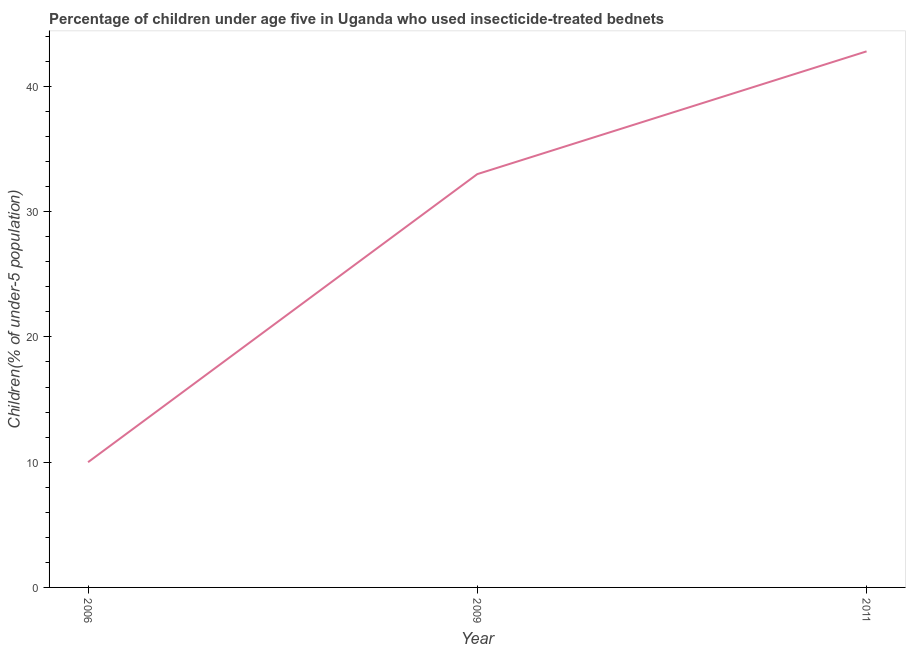What is the percentage of children who use of insecticide-treated bed nets in 2009?
Provide a short and direct response. 33. Across all years, what is the maximum percentage of children who use of insecticide-treated bed nets?
Keep it short and to the point. 42.8. In which year was the percentage of children who use of insecticide-treated bed nets maximum?
Give a very brief answer. 2011. What is the sum of the percentage of children who use of insecticide-treated bed nets?
Provide a succinct answer. 85.8. What is the average percentage of children who use of insecticide-treated bed nets per year?
Provide a short and direct response. 28.6. In how many years, is the percentage of children who use of insecticide-treated bed nets greater than 24 %?
Your response must be concise. 2. What is the ratio of the percentage of children who use of insecticide-treated bed nets in 2006 to that in 2009?
Make the answer very short. 0.3. Is the percentage of children who use of insecticide-treated bed nets in 2006 less than that in 2009?
Provide a succinct answer. Yes. Is the difference between the percentage of children who use of insecticide-treated bed nets in 2006 and 2011 greater than the difference between any two years?
Make the answer very short. Yes. What is the difference between the highest and the second highest percentage of children who use of insecticide-treated bed nets?
Provide a short and direct response. 9.8. What is the difference between the highest and the lowest percentage of children who use of insecticide-treated bed nets?
Ensure brevity in your answer.  32.8. In how many years, is the percentage of children who use of insecticide-treated bed nets greater than the average percentage of children who use of insecticide-treated bed nets taken over all years?
Make the answer very short. 2. Does the percentage of children who use of insecticide-treated bed nets monotonically increase over the years?
Give a very brief answer. Yes. How many years are there in the graph?
Provide a succinct answer. 3. What is the difference between two consecutive major ticks on the Y-axis?
Offer a very short reply. 10. What is the title of the graph?
Make the answer very short. Percentage of children under age five in Uganda who used insecticide-treated bednets. What is the label or title of the X-axis?
Provide a succinct answer. Year. What is the label or title of the Y-axis?
Your response must be concise. Children(% of under-5 population). What is the Children(% of under-5 population) in 2011?
Your answer should be compact. 42.8. What is the difference between the Children(% of under-5 population) in 2006 and 2009?
Keep it short and to the point. -23. What is the difference between the Children(% of under-5 population) in 2006 and 2011?
Ensure brevity in your answer.  -32.8. What is the difference between the Children(% of under-5 population) in 2009 and 2011?
Your answer should be compact. -9.8. What is the ratio of the Children(% of under-5 population) in 2006 to that in 2009?
Your answer should be compact. 0.3. What is the ratio of the Children(% of under-5 population) in 2006 to that in 2011?
Your answer should be compact. 0.23. What is the ratio of the Children(% of under-5 population) in 2009 to that in 2011?
Ensure brevity in your answer.  0.77. 